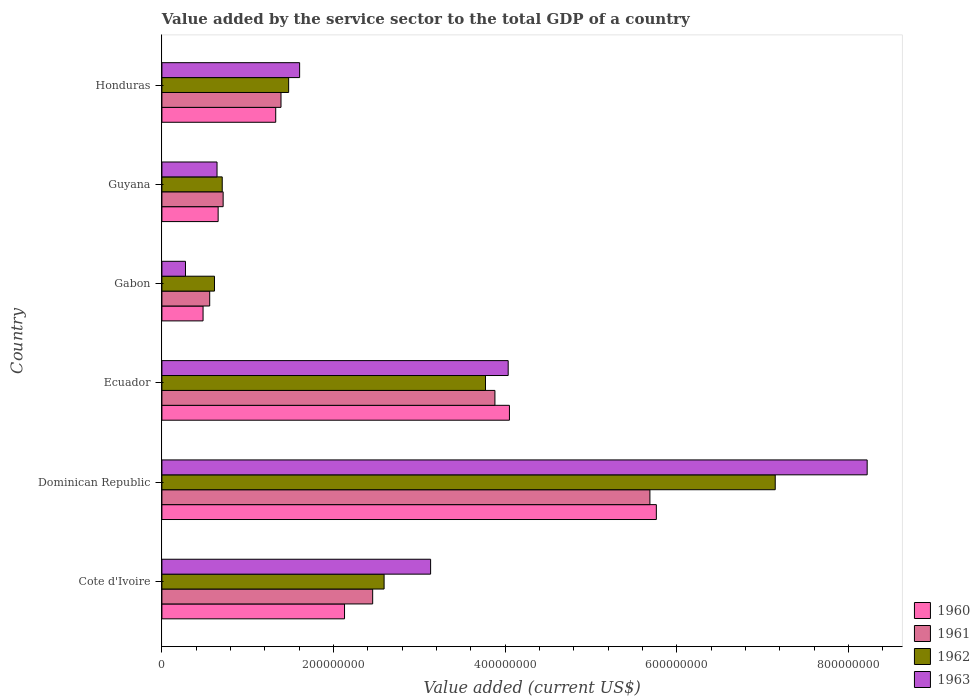How many different coloured bars are there?
Keep it short and to the point. 4. How many groups of bars are there?
Your response must be concise. 6. Are the number of bars per tick equal to the number of legend labels?
Give a very brief answer. Yes. Are the number of bars on each tick of the Y-axis equal?
Your answer should be very brief. Yes. How many bars are there on the 2nd tick from the top?
Keep it short and to the point. 4. How many bars are there on the 2nd tick from the bottom?
Provide a succinct answer. 4. What is the label of the 3rd group of bars from the top?
Provide a succinct answer. Gabon. What is the value added by the service sector to the total GDP in 1960 in Dominican Republic?
Ensure brevity in your answer.  5.76e+08. Across all countries, what is the maximum value added by the service sector to the total GDP in 1962?
Provide a succinct answer. 7.14e+08. Across all countries, what is the minimum value added by the service sector to the total GDP in 1960?
Offer a very short reply. 4.80e+07. In which country was the value added by the service sector to the total GDP in 1960 maximum?
Give a very brief answer. Dominican Republic. In which country was the value added by the service sector to the total GDP in 1963 minimum?
Offer a very short reply. Gabon. What is the total value added by the service sector to the total GDP in 1962 in the graph?
Offer a very short reply. 1.63e+09. What is the difference between the value added by the service sector to the total GDP in 1963 in Ecuador and that in Gabon?
Your answer should be very brief. 3.76e+08. What is the difference between the value added by the service sector to the total GDP in 1960 in Gabon and the value added by the service sector to the total GDP in 1962 in Ecuador?
Offer a terse response. -3.29e+08. What is the average value added by the service sector to the total GDP in 1963 per country?
Your answer should be very brief. 2.98e+08. What is the difference between the value added by the service sector to the total GDP in 1961 and value added by the service sector to the total GDP in 1962 in Gabon?
Ensure brevity in your answer.  -5.57e+06. What is the ratio of the value added by the service sector to the total GDP in 1960 in Cote d'Ivoire to that in Gabon?
Make the answer very short. 4.44. Is the difference between the value added by the service sector to the total GDP in 1961 in Dominican Republic and Ecuador greater than the difference between the value added by the service sector to the total GDP in 1962 in Dominican Republic and Ecuador?
Offer a terse response. No. What is the difference between the highest and the second highest value added by the service sector to the total GDP in 1963?
Make the answer very short. 4.18e+08. What is the difference between the highest and the lowest value added by the service sector to the total GDP in 1963?
Provide a succinct answer. 7.94e+08. What does the 3rd bar from the bottom in Guyana represents?
Keep it short and to the point. 1962. What is the difference between two consecutive major ticks on the X-axis?
Your answer should be compact. 2.00e+08. Where does the legend appear in the graph?
Keep it short and to the point. Bottom right. How many legend labels are there?
Your answer should be very brief. 4. What is the title of the graph?
Keep it short and to the point. Value added by the service sector to the total GDP of a country. What is the label or title of the X-axis?
Provide a succinct answer. Value added (current US$). What is the label or title of the Y-axis?
Provide a succinct answer. Country. What is the Value added (current US$) in 1960 in Cote d'Ivoire?
Offer a very short reply. 2.13e+08. What is the Value added (current US$) in 1961 in Cote d'Ivoire?
Provide a short and direct response. 2.46e+08. What is the Value added (current US$) of 1962 in Cote d'Ivoire?
Offer a terse response. 2.59e+08. What is the Value added (current US$) in 1963 in Cote d'Ivoire?
Your response must be concise. 3.13e+08. What is the Value added (current US$) of 1960 in Dominican Republic?
Provide a succinct answer. 5.76e+08. What is the Value added (current US$) in 1961 in Dominican Republic?
Offer a terse response. 5.68e+08. What is the Value added (current US$) of 1962 in Dominican Republic?
Give a very brief answer. 7.14e+08. What is the Value added (current US$) of 1963 in Dominican Republic?
Your answer should be very brief. 8.22e+08. What is the Value added (current US$) in 1960 in Ecuador?
Your answer should be very brief. 4.05e+08. What is the Value added (current US$) in 1961 in Ecuador?
Make the answer very short. 3.88e+08. What is the Value added (current US$) of 1962 in Ecuador?
Your response must be concise. 3.77e+08. What is the Value added (current US$) in 1963 in Ecuador?
Offer a very short reply. 4.03e+08. What is the Value added (current US$) in 1960 in Gabon?
Give a very brief answer. 4.80e+07. What is the Value added (current US$) of 1961 in Gabon?
Provide a short and direct response. 5.57e+07. What is the Value added (current US$) of 1962 in Gabon?
Offer a very short reply. 6.13e+07. What is the Value added (current US$) in 1963 in Gabon?
Give a very brief answer. 2.75e+07. What is the Value added (current US$) in 1960 in Guyana?
Your response must be concise. 6.55e+07. What is the Value added (current US$) of 1961 in Guyana?
Provide a succinct answer. 7.13e+07. What is the Value added (current US$) of 1962 in Guyana?
Your answer should be compact. 7.03e+07. What is the Value added (current US$) of 1963 in Guyana?
Your answer should be very brief. 6.42e+07. What is the Value added (current US$) in 1960 in Honduras?
Provide a short and direct response. 1.33e+08. What is the Value added (current US$) of 1961 in Honduras?
Make the answer very short. 1.39e+08. What is the Value added (current US$) in 1962 in Honduras?
Provide a succinct answer. 1.48e+08. What is the Value added (current US$) of 1963 in Honduras?
Keep it short and to the point. 1.60e+08. Across all countries, what is the maximum Value added (current US$) of 1960?
Provide a short and direct response. 5.76e+08. Across all countries, what is the maximum Value added (current US$) of 1961?
Offer a terse response. 5.68e+08. Across all countries, what is the maximum Value added (current US$) in 1962?
Your response must be concise. 7.14e+08. Across all countries, what is the maximum Value added (current US$) in 1963?
Your answer should be compact. 8.22e+08. Across all countries, what is the minimum Value added (current US$) of 1960?
Offer a terse response. 4.80e+07. Across all countries, what is the minimum Value added (current US$) of 1961?
Your response must be concise. 5.57e+07. Across all countries, what is the minimum Value added (current US$) of 1962?
Provide a succinct answer. 6.13e+07. Across all countries, what is the minimum Value added (current US$) of 1963?
Offer a very short reply. 2.75e+07. What is the total Value added (current US$) of 1960 in the graph?
Your response must be concise. 1.44e+09. What is the total Value added (current US$) of 1961 in the graph?
Your response must be concise. 1.47e+09. What is the total Value added (current US$) of 1962 in the graph?
Your answer should be very brief. 1.63e+09. What is the total Value added (current US$) of 1963 in the graph?
Provide a succinct answer. 1.79e+09. What is the difference between the Value added (current US$) in 1960 in Cote d'Ivoire and that in Dominican Republic?
Keep it short and to the point. -3.63e+08. What is the difference between the Value added (current US$) in 1961 in Cote d'Ivoire and that in Dominican Republic?
Ensure brevity in your answer.  -3.23e+08. What is the difference between the Value added (current US$) of 1962 in Cote d'Ivoire and that in Dominican Republic?
Give a very brief answer. -4.56e+08. What is the difference between the Value added (current US$) of 1963 in Cote d'Ivoire and that in Dominican Republic?
Make the answer very short. -5.09e+08. What is the difference between the Value added (current US$) of 1960 in Cote d'Ivoire and that in Ecuador?
Offer a very short reply. -1.92e+08. What is the difference between the Value added (current US$) of 1961 in Cote d'Ivoire and that in Ecuador?
Your response must be concise. -1.42e+08. What is the difference between the Value added (current US$) of 1962 in Cote d'Ivoire and that in Ecuador?
Offer a terse response. -1.18e+08. What is the difference between the Value added (current US$) in 1963 in Cote d'Ivoire and that in Ecuador?
Offer a very short reply. -9.04e+07. What is the difference between the Value added (current US$) in 1960 in Cote d'Ivoire and that in Gabon?
Your response must be concise. 1.65e+08. What is the difference between the Value added (current US$) of 1961 in Cote d'Ivoire and that in Gabon?
Your response must be concise. 1.90e+08. What is the difference between the Value added (current US$) of 1962 in Cote d'Ivoire and that in Gabon?
Ensure brevity in your answer.  1.98e+08. What is the difference between the Value added (current US$) in 1963 in Cote d'Ivoire and that in Gabon?
Offer a terse response. 2.86e+08. What is the difference between the Value added (current US$) of 1960 in Cote d'Ivoire and that in Guyana?
Offer a terse response. 1.47e+08. What is the difference between the Value added (current US$) of 1961 in Cote d'Ivoire and that in Guyana?
Your answer should be very brief. 1.74e+08. What is the difference between the Value added (current US$) in 1962 in Cote d'Ivoire and that in Guyana?
Offer a terse response. 1.89e+08. What is the difference between the Value added (current US$) of 1963 in Cote d'Ivoire and that in Guyana?
Offer a very short reply. 2.49e+08. What is the difference between the Value added (current US$) in 1960 in Cote d'Ivoire and that in Honduras?
Offer a very short reply. 8.02e+07. What is the difference between the Value added (current US$) of 1961 in Cote d'Ivoire and that in Honduras?
Your answer should be very brief. 1.07e+08. What is the difference between the Value added (current US$) in 1962 in Cote d'Ivoire and that in Honduras?
Your answer should be compact. 1.11e+08. What is the difference between the Value added (current US$) of 1963 in Cote d'Ivoire and that in Honduras?
Give a very brief answer. 1.53e+08. What is the difference between the Value added (current US$) of 1960 in Dominican Republic and that in Ecuador?
Offer a terse response. 1.71e+08. What is the difference between the Value added (current US$) of 1961 in Dominican Republic and that in Ecuador?
Keep it short and to the point. 1.81e+08. What is the difference between the Value added (current US$) in 1962 in Dominican Republic and that in Ecuador?
Make the answer very short. 3.38e+08. What is the difference between the Value added (current US$) in 1963 in Dominican Republic and that in Ecuador?
Offer a terse response. 4.18e+08. What is the difference between the Value added (current US$) in 1960 in Dominican Republic and that in Gabon?
Give a very brief answer. 5.28e+08. What is the difference between the Value added (current US$) in 1961 in Dominican Republic and that in Gabon?
Provide a succinct answer. 5.13e+08. What is the difference between the Value added (current US$) in 1962 in Dominican Republic and that in Gabon?
Offer a terse response. 6.53e+08. What is the difference between the Value added (current US$) in 1963 in Dominican Republic and that in Gabon?
Keep it short and to the point. 7.94e+08. What is the difference between the Value added (current US$) in 1960 in Dominican Republic and that in Guyana?
Your answer should be very brief. 5.10e+08. What is the difference between the Value added (current US$) of 1961 in Dominican Republic and that in Guyana?
Your response must be concise. 4.97e+08. What is the difference between the Value added (current US$) in 1962 in Dominican Republic and that in Guyana?
Provide a succinct answer. 6.44e+08. What is the difference between the Value added (current US$) in 1963 in Dominican Republic and that in Guyana?
Provide a succinct answer. 7.57e+08. What is the difference between the Value added (current US$) of 1960 in Dominican Republic and that in Honduras?
Ensure brevity in your answer.  4.43e+08. What is the difference between the Value added (current US$) in 1961 in Dominican Republic and that in Honduras?
Ensure brevity in your answer.  4.30e+08. What is the difference between the Value added (current US$) of 1962 in Dominican Republic and that in Honduras?
Provide a succinct answer. 5.67e+08. What is the difference between the Value added (current US$) of 1963 in Dominican Republic and that in Honduras?
Make the answer very short. 6.61e+08. What is the difference between the Value added (current US$) of 1960 in Ecuador and that in Gabon?
Ensure brevity in your answer.  3.57e+08. What is the difference between the Value added (current US$) in 1961 in Ecuador and that in Gabon?
Offer a terse response. 3.32e+08. What is the difference between the Value added (current US$) in 1962 in Ecuador and that in Gabon?
Your response must be concise. 3.16e+08. What is the difference between the Value added (current US$) of 1963 in Ecuador and that in Gabon?
Provide a succinct answer. 3.76e+08. What is the difference between the Value added (current US$) in 1960 in Ecuador and that in Guyana?
Offer a terse response. 3.39e+08. What is the difference between the Value added (current US$) in 1961 in Ecuador and that in Guyana?
Your answer should be very brief. 3.17e+08. What is the difference between the Value added (current US$) of 1962 in Ecuador and that in Guyana?
Your answer should be very brief. 3.07e+08. What is the difference between the Value added (current US$) in 1963 in Ecuador and that in Guyana?
Offer a terse response. 3.39e+08. What is the difference between the Value added (current US$) in 1960 in Ecuador and that in Honduras?
Ensure brevity in your answer.  2.72e+08. What is the difference between the Value added (current US$) in 1961 in Ecuador and that in Honduras?
Keep it short and to the point. 2.49e+08. What is the difference between the Value added (current US$) of 1962 in Ecuador and that in Honduras?
Your answer should be compact. 2.29e+08. What is the difference between the Value added (current US$) in 1963 in Ecuador and that in Honduras?
Provide a succinct answer. 2.43e+08. What is the difference between the Value added (current US$) of 1960 in Gabon and that in Guyana?
Keep it short and to the point. -1.76e+07. What is the difference between the Value added (current US$) in 1961 in Gabon and that in Guyana?
Your answer should be very brief. -1.56e+07. What is the difference between the Value added (current US$) in 1962 in Gabon and that in Guyana?
Keep it short and to the point. -9.03e+06. What is the difference between the Value added (current US$) in 1963 in Gabon and that in Guyana?
Provide a short and direct response. -3.68e+07. What is the difference between the Value added (current US$) in 1960 in Gabon and that in Honduras?
Your answer should be compact. -8.46e+07. What is the difference between the Value added (current US$) in 1961 in Gabon and that in Honduras?
Provide a succinct answer. -8.31e+07. What is the difference between the Value added (current US$) in 1962 in Gabon and that in Honduras?
Give a very brief answer. -8.64e+07. What is the difference between the Value added (current US$) of 1963 in Gabon and that in Honduras?
Keep it short and to the point. -1.33e+08. What is the difference between the Value added (current US$) of 1960 in Guyana and that in Honduras?
Your response must be concise. -6.71e+07. What is the difference between the Value added (current US$) of 1961 in Guyana and that in Honduras?
Ensure brevity in your answer.  -6.74e+07. What is the difference between the Value added (current US$) in 1962 in Guyana and that in Honduras?
Offer a very short reply. -7.74e+07. What is the difference between the Value added (current US$) in 1963 in Guyana and that in Honduras?
Provide a succinct answer. -9.62e+07. What is the difference between the Value added (current US$) in 1960 in Cote d'Ivoire and the Value added (current US$) in 1961 in Dominican Republic?
Offer a very short reply. -3.56e+08. What is the difference between the Value added (current US$) of 1960 in Cote d'Ivoire and the Value added (current US$) of 1962 in Dominican Republic?
Keep it short and to the point. -5.02e+08. What is the difference between the Value added (current US$) of 1960 in Cote d'Ivoire and the Value added (current US$) of 1963 in Dominican Republic?
Your answer should be very brief. -6.09e+08. What is the difference between the Value added (current US$) in 1961 in Cote d'Ivoire and the Value added (current US$) in 1962 in Dominican Republic?
Provide a short and direct response. -4.69e+08. What is the difference between the Value added (current US$) of 1961 in Cote d'Ivoire and the Value added (current US$) of 1963 in Dominican Republic?
Your response must be concise. -5.76e+08. What is the difference between the Value added (current US$) of 1962 in Cote d'Ivoire and the Value added (current US$) of 1963 in Dominican Republic?
Provide a succinct answer. -5.63e+08. What is the difference between the Value added (current US$) of 1960 in Cote d'Ivoire and the Value added (current US$) of 1961 in Ecuador?
Make the answer very short. -1.75e+08. What is the difference between the Value added (current US$) in 1960 in Cote d'Ivoire and the Value added (current US$) in 1962 in Ecuador?
Provide a short and direct response. -1.64e+08. What is the difference between the Value added (current US$) in 1960 in Cote d'Ivoire and the Value added (current US$) in 1963 in Ecuador?
Your response must be concise. -1.91e+08. What is the difference between the Value added (current US$) of 1961 in Cote d'Ivoire and the Value added (current US$) of 1962 in Ecuador?
Provide a short and direct response. -1.31e+08. What is the difference between the Value added (current US$) of 1961 in Cote d'Ivoire and the Value added (current US$) of 1963 in Ecuador?
Ensure brevity in your answer.  -1.58e+08. What is the difference between the Value added (current US$) in 1962 in Cote d'Ivoire and the Value added (current US$) in 1963 in Ecuador?
Provide a short and direct response. -1.45e+08. What is the difference between the Value added (current US$) of 1960 in Cote d'Ivoire and the Value added (current US$) of 1961 in Gabon?
Ensure brevity in your answer.  1.57e+08. What is the difference between the Value added (current US$) in 1960 in Cote d'Ivoire and the Value added (current US$) in 1962 in Gabon?
Offer a very short reply. 1.52e+08. What is the difference between the Value added (current US$) of 1960 in Cote d'Ivoire and the Value added (current US$) of 1963 in Gabon?
Provide a short and direct response. 1.85e+08. What is the difference between the Value added (current US$) of 1961 in Cote d'Ivoire and the Value added (current US$) of 1962 in Gabon?
Make the answer very short. 1.84e+08. What is the difference between the Value added (current US$) in 1961 in Cote d'Ivoire and the Value added (current US$) in 1963 in Gabon?
Keep it short and to the point. 2.18e+08. What is the difference between the Value added (current US$) of 1962 in Cote d'Ivoire and the Value added (current US$) of 1963 in Gabon?
Provide a short and direct response. 2.31e+08. What is the difference between the Value added (current US$) of 1960 in Cote d'Ivoire and the Value added (current US$) of 1961 in Guyana?
Ensure brevity in your answer.  1.41e+08. What is the difference between the Value added (current US$) of 1960 in Cote d'Ivoire and the Value added (current US$) of 1962 in Guyana?
Keep it short and to the point. 1.42e+08. What is the difference between the Value added (current US$) of 1960 in Cote d'Ivoire and the Value added (current US$) of 1963 in Guyana?
Ensure brevity in your answer.  1.49e+08. What is the difference between the Value added (current US$) in 1961 in Cote d'Ivoire and the Value added (current US$) in 1962 in Guyana?
Provide a succinct answer. 1.75e+08. What is the difference between the Value added (current US$) in 1961 in Cote d'Ivoire and the Value added (current US$) in 1963 in Guyana?
Your response must be concise. 1.81e+08. What is the difference between the Value added (current US$) in 1962 in Cote d'Ivoire and the Value added (current US$) in 1963 in Guyana?
Keep it short and to the point. 1.95e+08. What is the difference between the Value added (current US$) of 1960 in Cote d'Ivoire and the Value added (current US$) of 1961 in Honduras?
Provide a succinct answer. 7.40e+07. What is the difference between the Value added (current US$) of 1960 in Cote d'Ivoire and the Value added (current US$) of 1962 in Honduras?
Keep it short and to the point. 6.51e+07. What is the difference between the Value added (current US$) in 1960 in Cote d'Ivoire and the Value added (current US$) in 1963 in Honduras?
Provide a short and direct response. 5.23e+07. What is the difference between the Value added (current US$) in 1961 in Cote d'Ivoire and the Value added (current US$) in 1962 in Honduras?
Offer a very short reply. 9.79e+07. What is the difference between the Value added (current US$) of 1961 in Cote d'Ivoire and the Value added (current US$) of 1963 in Honduras?
Your answer should be compact. 8.51e+07. What is the difference between the Value added (current US$) in 1962 in Cote d'Ivoire and the Value added (current US$) in 1963 in Honduras?
Give a very brief answer. 9.84e+07. What is the difference between the Value added (current US$) of 1960 in Dominican Republic and the Value added (current US$) of 1961 in Ecuador?
Keep it short and to the point. 1.88e+08. What is the difference between the Value added (current US$) of 1960 in Dominican Republic and the Value added (current US$) of 1962 in Ecuador?
Make the answer very short. 1.99e+08. What is the difference between the Value added (current US$) of 1960 in Dominican Republic and the Value added (current US$) of 1963 in Ecuador?
Your answer should be very brief. 1.73e+08. What is the difference between the Value added (current US$) in 1961 in Dominican Republic and the Value added (current US$) in 1962 in Ecuador?
Provide a short and direct response. 1.92e+08. What is the difference between the Value added (current US$) in 1961 in Dominican Republic and the Value added (current US$) in 1963 in Ecuador?
Keep it short and to the point. 1.65e+08. What is the difference between the Value added (current US$) in 1962 in Dominican Republic and the Value added (current US$) in 1963 in Ecuador?
Offer a terse response. 3.11e+08. What is the difference between the Value added (current US$) in 1960 in Dominican Republic and the Value added (current US$) in 1961 in Gabon?
Offer a very short reply. 5.20e+08. What is the difference between the Value added (current US$) in 1960 in Dominican Republic and the Value added (current US$) in 1962 in Gabon?
Your response must be concise. 5.15e+08. What is the difference between the Value added (current US$) of 1960 in Dominican Republic and the Value added (current US$) of 1963 in Gabon?
Ensure brevity in your answer.  5.49e+08. What is the difference between the Value added (current US$) of 1961 in Dominican Republic and the Value added (current US$) of 1962 in Gabon?
Provide a succinct answer. 5.07e+08. What is the difference between the Value added (current US$) in 1961 in Dominican Republic and the Value added (current US$) in 1963 in Gabon?
Offer a very short reply. 5.41e+08. What is the difference between the Value added (current US$) in 1962 in Dominican Republic and the Value added (current US$) in 1963 in Gabon?
Ensure brevity in your answer.  6.87e+08. What is the difference between the Value added (current US$) of 1960 in Dominican Republic and the Value added (current US$) of 1961 in Guyana?
Provide a succinct answer. 5.05e+08. What is the difference between the Value added (current US$) of 1960 in Dominican Republic and the Value added (current US$) of 1962 in Guyana?
Make the answer very short. 5.06e+08. What is the difference between the Value added (current US$) of 1960 in Dominican Republic and the Value added (current US$) of 1963 in Guyana?
Provide a succinct answer. 5.12e+08. What is the difference between the Value added (current US$) in 1961 in Dominican Republic and the Value added (current US$) in 1962 in Guyana?
Your response must be concise. 4.98e+08. What is the difference between the Value added (current US$) of 1961 in Dominican Republic and the Value added (current US$) of 1963 in Guyana?
Give a very brief answer. 5.04e+08. What is the difference between the Value added (current US$) in 1962 in Dominican Republic and the Value added (current US$) in 1963 in Guyana?
Offer a very short reply. 6.50e+08. What is the difference between the Value added (current US$) of 1960 in Dominican Republic and the Value added (current US$) of 1961 in Honduras?
Provide a short and direct response. 4.37e+08. What is the difference between the Value added (current US$) in 1960 in Dominican Republic and the Value added (current US$) in 1962 in Honduras?
Offer a terse response. 4.28e+08. What is the difference between the Value added (current US$) in 1960 in Dominican Republic and the Value added (current US$) in 1963 in Honduras?
Your answer should be compact. 4.16e+08. What is the difference between the Value added (current US$) of 1961 in Dominican Republic and the Value added (current US$) of 1962 in Honduras?
Provide a succinct answer. 4.21e+08. What is the difference between the Value added (current US$) in 1961 in Dominican Republic and the Value added (current US$) in 1963 in Honduras?
Your response must be concise. 4.08e+08. What is the difference between the Value added (current US$) of 1962 in Dominican Republic and the Value added (current US$) of 1963 in Honduras?
Keep it short and to the point. 5.54e+08. What is the difference between the Value added (current US$) of 1960 in Ecuador and the Value added (current US$) of 1961 in Gabon?
Your answer should be very brief. 3.49e+08. What is the difference between the Value added (current US$) in 1960 in Ecuador and the Value added (current US$) in 1962 in Gabon?
Provide a succinct answer. 3.44e+08. What is the difference between the Value added (current US$) of 1960 in Ecuador and the Value added (current US$) of 1963 in Gabon?
Offer a very short reply. 3.77e+08. What is the difference between the Value added (current US$) in 1961 in Ecuador and the Value added (current US$) in 1962 in Gabon?
Offer a very short reply. 3.27e+08. What is the difference between the Value added (current US$) of 1961 in Ecuador and the Value added (current US$) of 1963 in Gabon?
Your answer should be very brief. 3.60e+08. What is the difference between the Value added (current US$) in 1962 in Ecuador and the Value added (current US$) in 1963 in Gabon?
Make the answer very short. 3.49e+08. What is the difference between the Value added (current US$) of 1960 in Ecuador and the Value added (current US$) of 1961 in Guyana?
Provide a succinct answer. 3.34e+08. What is the difference between the Value added (current US$) in 1960 in Ecuador and the Value added (current US$) in 1962 in Guyana?
Keep it short and to the point. 3.35e+08. What is the difference between the Value added (current US$) in 1960 in Ecuador and the Value added (current US$) in 1963 in Guyana?
Offer a very short reply. 3.41e+08. What is the difference between the Value added (current US$) of 1961 in Ecuador and the Value added (current US$) of 1962 in Guyana?
Keep it short and to the point. 3.18e+08. What is the difference between the Value added (current US$) in 1961 in Ecuador and the Value added (current US$) in 1963 in Guyana?
Give a very brief answer. 3.24e+08. What is the difference between the Value added (current US$) in 1962 in Ecuador and the Value added (current US$) in 1963 in Guyana?
Offer a terse response. 3.13e+08. What is the difference between the Value added (current US$) of 1960 in Ecuador and the Value added (current US$) of 1961 in Honduras?
Your answer should be compact. 2.66e+08. What is the difference between the Value added (current US$) of 1960 in Ecuador and the Value added (current US$) of 1962 in Honduras?
Offer a very short reply. 2.57e+08. What is the difference between the Value added (current US$) in 1960 in Ecuador and the Value added (current US$) in 1963 in Honduras?
Your answer should be compact. 2.44e+08. What is the difference between the Value added (current US$) of 1961 in Ecuador and the Value added (current US$) of 1962 in Honduras?
Offer a very short reply. 2.40e+08. What is the difference between the Value added (current US$) in 1961 in Ecuador and the Value added (current US$) in 1963 in Honduras?
Keep it short and to the point. 2.28e+08. What is the difference between the Value added (current US$) in 1962 in Ecuador and the Value added (current US$) in 1963 in Honduras?
Provide a short and direct response. 2.17e+08. What is the difference between the Value added (current US$) in 1960 in Gabon and the Value added (current US$) in 1961 in Guyana?
Your answer should be very brief. -2.34e+07. What is the difference between the Value added (current US$) in 1960 in Gabon and the Value added (current US$) in 1962 in Guyana?
Give a very brief answer. -2.23e+07. What is the difference between the Value added (current US$) of 1960 in Gabon and the Value added (current US$) of 1963 in Guyana?
Offer a terse response. -1.63e+07. What is the difference between the Value added (current US$) of 1961 in Gabon and the Value added (current US$) of 1962 in Guyana?
Make the answer very short. -1.46e+07. What is the difference between the Value added (current US$) in 1961 in Gabon and the Value added (current US$) in 1963 in Guyana?
Keep it short and to the point. -8.53e+06. What is the difference between the Value added (current US$) in 1962 in Gabon and the Value added (current US$) in 1963 in Guyana?
Provide a succinct answer. -2.96e+06. What is the difference between the Value added (current US$) of 1960 in Gabon and the Value added (current US$) of 1961 in Honduras?
Your answer should be compact. -9.08e+07. What is the difference between the Value added (current US$) of 1960 in Gabon and the Value added (current US$) of 1962 in Honduras?
Offer a very short reply. -9.97e+07. What is the difference between the Value added (current US$) of 1960 in Gabon and the Value added (current US$) of 1963 in Honduras?
Your answer should be compact. -1.12e+08. What is the difference between the Value added (current US$) in 1961 in Gabon and the Value added (current US$) in 1962 in Honduras?
Your response must be concise. -9.20e+07. What is the difference between the Value added (current US$) in 1961 in Gabon and the Value added (current US$) in 1963 in Honduras?
Keep it short and to the point. -1.05e+08. What is the difference between the Value added (current US$) of 1962 in Gabon and the Value added (current US$) of 1963 in Honduras?
Ensure brevity in your answer.  -9.92e+07. What is the difference between the Value added (current US$) of 1960 in Guyana and the Value added (current US$) of 1961 in Honduras?
Ensure brevity in your answer.  -7.32e+07. What is the difference between the Value added (current US$) in 1960 in Guyana and the Value added (current US$) in 1962 in Honduras?
Provide a short and direct response. -8.21e+07. What is the difference between the Value added (current US$) of 1960 in Guyana and the Value added (current US$) of 1963 in Honduras?
Make the answer very short. -9.49e+07. What is the difference between the Value added (current US$) of 1961 in Guyana and the Value added (current US$) of 1962 in Honduras?
Provide a succinct answer. -7.63e+07. What is the difference between the Value added (current US$) in 1961 in Guyana and the Value added (current US$) in 1963 in Honduras?
Make the answer very short. -8.91e+07. What is the difference between the Value added (current US$) in 1962 in Guyana and the Value added (current US$) in 1963 in Honduras?
Keep it short and to the point. -9.02e+07. What is the average Value added (current US$) in 1960 per country?
Ensure brevity in your answer.  2.40e+08. What is the average Value added (current US$) in 1961 per country?
Your response must be concise. 2.45e+08. What is the average Value added (current US$) in 1962 per country?
Make the answer very short. 2.72e+08. What is the average Value added (current US$) in 1963 per country?
Your response must be concise. 2.98e+08. What is the difference between the Value added (current US$) in 1960 and Value added (current US$) in 1961 in Cote d'Ivoire?
Offer a terse response. -3.28e+07. What is the difference between the Value added (current US$) in 1960 and Value added (current US$) in 1962 in Cote d'Ivoire?
Make the answer very short. -4.61e+07. What is the difference between the Value added (current US$) in 1960 and Value added (current US$) in 1963 in Cote d'Ivoire?
Your answer should be compact. -1.00e+08. What is the difference between the Value added (current US$) of 1961 and Value added (current US$) of 1962 in Cote d'Ivoire?
Give a very brief answer. -1.33e+07. What is the difference between the Value added (current US$) of 1961 and Value added (current US$) of 1963 in Cote d'Ivoire?
Provide a short and direct response. -6.75e+07. What is the difference between the Value added (current US$) in 1962 and Value added (current US$) in 1963 in Cote d'Ivoire?
Make the answer very short. -5.42e+07. What is the difference between the Value added (current US$) of 1960 and Value added (current US$) of 1961 in Dominican Republic?
Offer a terse response. 7.50e+06. What is the difference between the Value added (current US$) of 1960 and Value added (current US$) of 1962 in Dominican Republic?
Offer a terse response. -1.39e+08. What is the difference between the Value added (current US$) of 1960 and Value added (current US$) of 1963 in Dominican Republic?
Keep it short and to the point. -2.46e+08. What is the difference between the Value added (current US$) of 1961 and Value added (current US$) of 1962 in Dominican Republic?
Keep it short and to the point. -1.46e+08. What is the difference between the Value added (current US$) in 1961 and Value added (current US$) in 1963 in Dominican Republic?
Keep it short and to the point. -2.53e+08. What is the difference between the Value added (current US$) in 1962 and Value added (current US$) in 1963 in Dominican Republic?
Ensure brevity in your answer.  -1.07e+08. What is the difference between the Value added (current US$) in 1960 and Value added (current US$) in 1961 in Ecuador?
Offer a terse response. 1.69e+07. What is the difference between the Value added (current US$) in 1960 and Value added (current US$) in 1962 in Ecuador?
Give a very brief answer. 2.79e+07. What is the difference between the Value added (current US$) in 1960 and Value added (current US$) in 1963 in Ecuador?
Your answer should be very brief. 1.47e+06. What is the difference between the Value added (current US$) in 1961 and Value added (current US$) in 1962 in Ecuador?
Provide a succinct answer. 1.10e+07. What is the difference between the Value added (current US$) of 1961 and Value added (current US$) of 1963 in Ecuador?
Keep it short and to the point. -1.54e+07. What is the difference between the Value added (current US$) in 1962 and Value added (current US$) in 1963 in Ecuador?
Offer a terse response. -2.64e+07. What is the difference between the Value added (current US$) of 1960 and Value added (current US$) of 1961 in Gabon?
Ensure brevity in your answer.  -7.74e+06. What is the difference between the Value added (current US$) of 1960 and Value added (current US$) of 1962 in Gabon?
Ensure brevity in your answer.  -1.33e+07. What is the difference between the Value added (current US$) in 1960 and Value added (current US$) in 1963 in Gabon?
Your answer should be compact. 2.05e+07. What is the difference between the Value added (current US$) in 1961 and Value added (current US$) in 1962 in Gabon?
Provide a short and direct response. -5.57e+06. What is the difference between the Value added (current US$) of 1961 and Value added (current US$) of 1963 in Gabon?
Make the answer very short. 2.82e+07. What is the difference between the Value added (current US$) of 1962 and Value added (current US$) of 1963 in Gabon?
Offer a terse response. 3.38e+07. What is the difference between the Value added (current US$) of 1960 and Value added (current US$) of 1961 in Guyana?
Offer a terse response. -5.83e+06. What is the difference between the Value added (current US$) in 1960 and Value added (current US$) in 1962 in Guyana?
Provide a succinct answer. -4.78e+06. What is the difference between the Value added (current US$) of 1960 and Value added (current US$) of 1963 in Guyana?
Offer a very short reply. 1.28e+06. What is the difference between the Value added (current US$) in 1961 and Value added (current US$) in 1962 in Guyana?
Make the answer very short. 1.05e+06. What is the difference between the Value added (current US$) of 1961 and Value added (current US$) of 1963 in Guyana?
Offer a terse response. 7.12e+06. What is the difference between the Value added (current US$) of 1962 and Value added (current US$) of 1963 in Guyana?
Offer a terse response. 6.07e+06. What is the difference between the Value added (current US$) in 1960 and Value added (current US$) in 1961 in Honduras?
Make the answer very short. -6.15e+06. What is the difference between the Value added (current US$) in 1960 and Value added (current US$) in 1962 in Honduras?
Provide a succinct answer. -1.50e+07. What is the difference between the Value added (current US$) in 1960 and Value added (current US$) in 1963 in Honduras?
Provide a short and direct response. -2.78e+07. What is the difference between the Value added (current US$) in 1961 and Value added (current US$) in 1962 in Honduras?
Make the answer very short. -8.90e+06. What is the difference between the Value added (current US$) of 1961 and Value added (current US$) of 1963 in Honduras?
Make the answer very short. -2.17e+07. What is the difference between the Value added (current US$) of 1962 and Value added (current US$) of 1963 in Honduras?
Offer a very short reply. -1.28e+07. What is the ratio of the Value added (current US$) of 1960 in Cote d'Ivoire to that in Dominican Republic?
Your response must be concise. 0.37. What is the ratio of the Value added (current US$) in 1961 in Cote d'Ivoire to that in Dominican Republic?
Offer a very short reply. 0.43. What is the ratio of the Value added (current US$) of 1962 in Cote d'Ivoire to that in Dominican Republic?
Make the answer very short. 0.36. What is the ratio of the Value added (current US$) in 1963 in Cote d'Ivoire to that in Dominican Republic?
Make the answer very short. 0.38. What is the ratio of the Value added (current US$) of 1960 in Cote d'Ivoire to that in Ecuador?
Your response must be concise. 0.53. What is the ratio of the Value added (current US$) of 1961 in Cote d'Ivoire to that in Ecuador?
Offer a terse response. 0.63. What is the ratio of the Value added (current US$) in 1962 in Cote d'Ivoire to that in Ecuador?
Ensure brevity in your answer.  0.69. What is the ratio of the Value added (current US$) of 1963 in Cote d'Ivoire to that in Ecuador?
Give a very brief answer. 0.78. What is the ratio of the Value added (current US$) of 1960 in Cote d'Ivoire to that in Gabon?
Offer a terse response. 4.44. What is the ratio of the Value added (current US$) of 1961 in Cote d'Ivoire to that in Gabon?
Offer a very short reply. 4.41. What is the ratio of the Value added (current US$) in 1962 in Cote d'Ivoire to that in Gabon?
Your answer should be compact. 4.23. What is the ratio of the Value added (current US$) in 1963 in Cote d'Ivoire to that in Gabon?
Provide a succinct answer. 11.4. What is the ratio of the Value added (current US$) of 1960 in Cote d'Ivoire to that in Guyana?
Give a very brief answer. 3.25. What is the ratio of the Value added (current US$) in 1961 in Cote d'Ivoire to that in Guyana?
Provide a succinct answer. 3.44. What is the ratio of the Value added (current US$) of 1962 in Cote d'Ivoire to that in Guyana?
Give a very brief answer. 3.68. What is the ratio of the Value added (current US$) of 1963 in Cote d'Ivoire to that in Guyana?
Offer a very short reply. 4.87. What is the ratio of the Value added (current US$) in 1960 in Cote d'Ivoire to that in Honduras?
Ensure brevity in your answer.  1.6. What is the ratio of the Value added (current US$) in 1961 in Cote d'Ivoire to that in Honduras?
Your answer should be compact. 1.77. What is the ratio of the Value added (current US$) in 1962 in Cote d'Ivoire to that in Honduras?
Provide a short and direct response. 1.75. What is the ratio of the Value added (current US$) of 1963 in Cote d'Ivoire to that in Honduras?
Your answer should be compact. 1.95. What is the ratio of the Value added (current US$) in 1960 in Dominican Republic to that in Ecuador?
Offer a terse response. 1.42. What is the ratio of the Value added (current US$) in 1961 in Dominican Republic to that in Ecuador?
Make the answer very short. 1.47. What is the ratio of the Value added (current US$) in 1962 in Dominican Republic to that in Ecuador?
Keep it short and to the point. 1.9. What is the ratio of the Value added (current US$) of 1963 in Dominican Republic to that in Ecuador?
Keep it short and to the point. 2.04. What is the ratio of the Value added (current US$) in 1960 in Dominican Republic to that in Gabon?
Your response must be concise. 12.01. What is the ratio of the Value added (current US$) in 1961 in Dominican Republic to that in Gabon?
Make the answer very short. 10.21. What is the ratio of the Value added (current US$) in 1962 in Dominican Republic to that in Gabon?
Provide a succinct answer. 11.66. What is the ratio of the Value added (current US$) of 1963 in Dominican Republic to that in Gabon?
Ensure brevity in your answer.  29.91. What is the ratio of the Value added (current US$) of 1960 in Dominican Republic to that in Guyana?
Your response must be concise. 8.79. What is the ratio of the Value added (current US$) in 1961 in Dominican Republic to that in Guyana?
Provide a succinct answer. 7.97. What is the ratio of the Value added (current US$) of 1962 in Dominican Republic to that in Guyana?
Keep it short and to the point. 10.16. What is the ratio of the Value added (current US$) in 1963 in Dominican Republic to that in Guyana?
Provide a succinct answer. 12.79. What is the ratio of the Value added (current US$) in 1960 in Dominican Republic to that in Honduras?
Provide a short and direct response. 4.34. What is the ratio of the Value added (current US$) in 1961 in Dominican Republic to that in Honduras?
Keep it short and to the point. 4.1. What is the ratio of the Value added (current US$) in 1962 in Dominican Republic to that in Honduras?
Offer a terse response. 4.84. What is the ratio of the Value added (current US$) in 1963 in Dominican Republic to that in Honduras?
Your answer should be very brief. 5.12. What is the ratio of the Value added (current US$) in 1960 in Ecuador to that in Gabon?
Your response must be concise. 8.44. What is the ratio of the Value added (current US$) in 1961 in Ecuador to that in Gabon?
Your answer should be very brief. 6.97. What is the ratio of the Value added (current US$) in 1962 in Ecuador to that in Gabon?
Provide a short and direct response. 6.15. What is the ratio of the Value added (current US$) of 1963 in Ecuador to that in Gabon?
Ensure brevity in your answer.  14.68. What is the ratio of the Value added (current US$) in 1960 in Ecuador to that in Guyana?
Offer a terse response. 6.18. What is the ratio of the Value added (current US$) in 1961 in Ecuador to that in Guyana?
Offer a terse response. 5.44. What is the ratio of the Value added (current US$) of 1962 in Ecuador to that in Guyana?
Give a very brief answer. 5.36. What is the ratio of the Value added (current US$) in 1963 in Ecuador to that in Guyana?
Your answer should be very brief. 6.28. What is the ratio of the Value added (current US$) in 1960 in Ecuador to that in Honduras?
Offer a terse response. 3.05. What is the ratio of the Value added (current US$) in 1961 in Ecuador to that in Honduras?
Provide a short and direct response. 2.8. What is the ratio of the Value added (current US$) of 1962 in Ecuador to that in Honduras?
Ensure brevity in your answer.  2.55. What is the ratio of the Value added (current US$) of 1963 in Ecuador to that in Honduras?
Ensure brevity in your answer.  2.51. What is the ratio of the Value added (current US$) of 1960 in Gabon to that in Guyana?
Offer a very short reply. 0.73. What is the ratio of the Value added (current US$) in 1961 in Gabon to that in Guyana?
Your answer should be compact. 0.78. What is the ratio of the Value added (current US$) in 1962 in Gabon to that in Guyana?
Offer a very short reply. 0.87. What is the ratio of the Value added (current US$) in 1963 in Gabon to that in Guyana?
Your response must be concise. 0.43. What is the ratio of the Value added (current US$) of 1960 in Gabon to that in Honduras?
Make the answer very short. 0.36. What is the ratio of the Value added (current US$) in 1961 in Gabon to that in Honduras?
Provide a short and direct response. 0.4. What is the ratio of the Value added (current US$) of 1962 in Gabon to that in Honduras?
Offer a terse response. 0.41. What is the ratio of the Value added (current US$) in 1963 in Gabon to that in Honduras?
Keep it short and to the point. 0.17. What is the ratio of the Value added (current US$) in 1960 in Guyana to that in Honduras?
Provide a short and direct response. 0.49. What is the ratio of the Value added (current US$) of 1961 in Guyana to that in Honduras?
Make the answer very short. 0.51. What is the ratio of the Value added (current US$) in 1962 in Guyana to that in Honduras?
Keep it short and to the point. 0.48. What is the ratio of the Value added (current US$) in 1963 in Guyana to that in Honduras?
Give a very brief answer. 0.4. What is the difference between the highest and the second highest Value added (current US$) of 1960?
Provide a short and direct response. 1.71e+08. What is the difference between the highest and the second highest Value added (current US$) in 1961?
Your answer should be very brief. 1.81e+08. What is the difference between the highest and the second highest Value added (current US$) of 1962?
Offer a terse response. 3.38e+08. What is the difference between the highest and the second highest Value added (current US$) of 1963?
Make the answer very short. 4.18e+08. What is the difference between the highest and the lowest Value added (current US$) of 1960?
Your answer should be compact. 5.28e+08. What is the difference between the highest and the lowest Value added (current US$) in 1961?
Your response must be concise. 5.13e+08. What is the difference between the highest and the lowest Value added (current US$) of 1962?
Ensure brevity in your answer.  6.53e+08. What is the difference between the highest and the lowest Value added (current US$) in 1963?
Keep it short and to the point. 7.94e+08. 